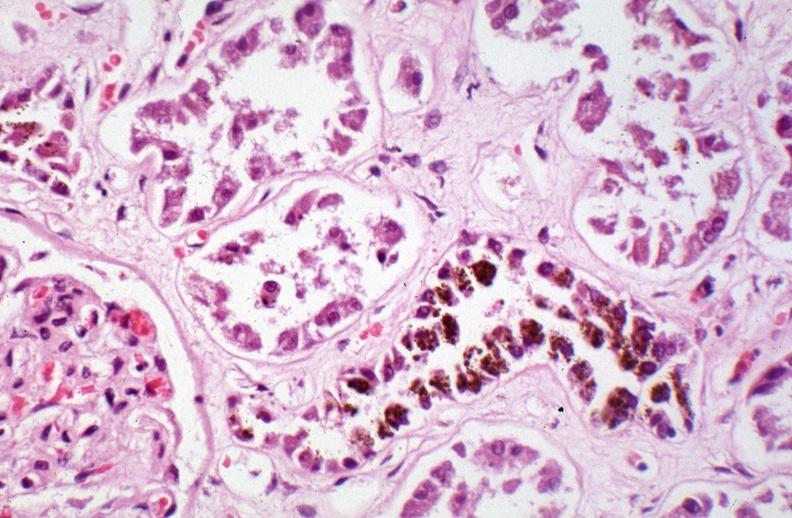where is this?
Answer the question using a single word or phrase. Urinary 